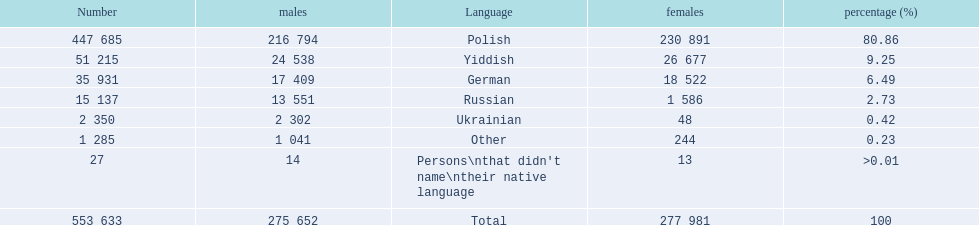What were the languages in plock governorate? Polish, Yiddish, German, Russian, Ukrainian, Other. Which language has a value of .42? Ukrainian. 